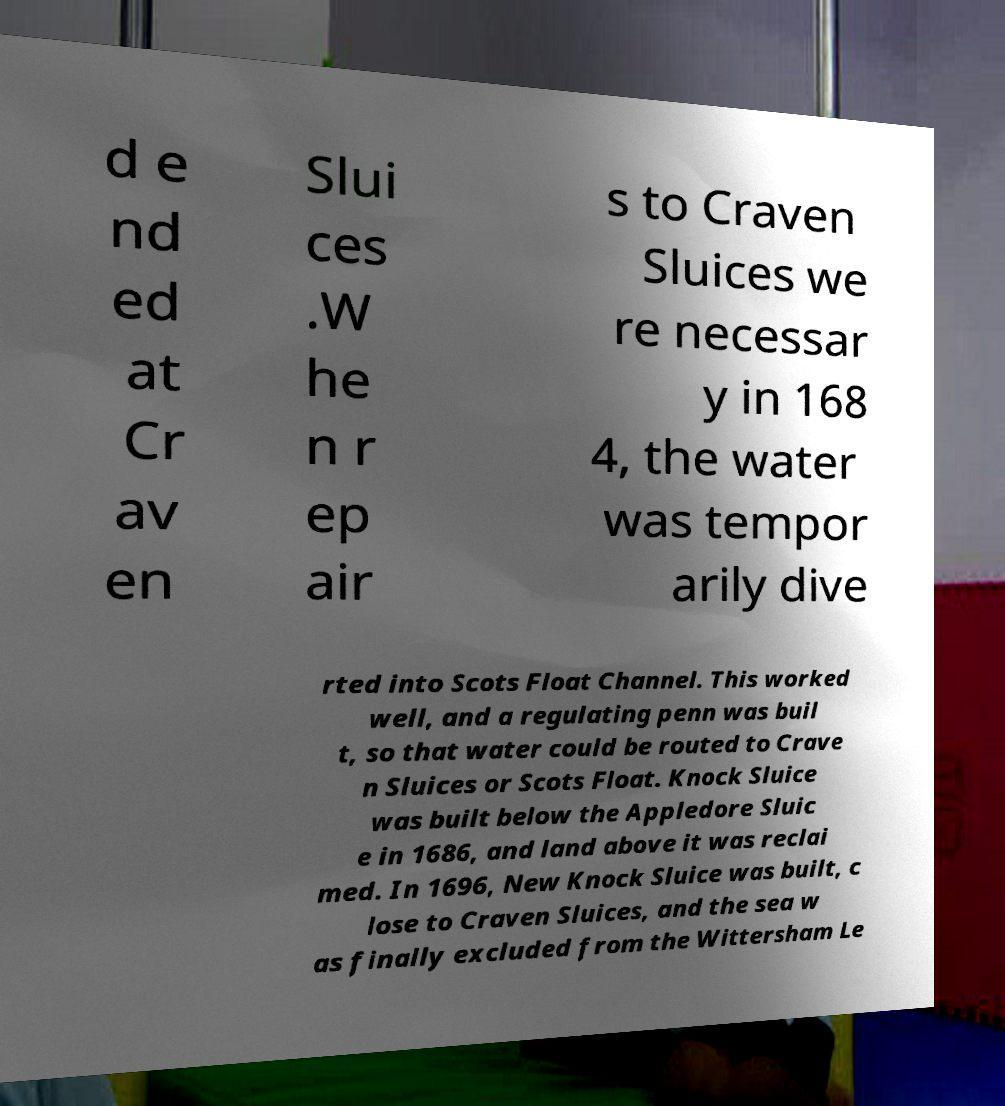Can you accurately transcribe the text from the provided image for me? d e nd ed at Cr av en Slui ces .W he n r ep air s to Craven Sluices we re necessar y in 168 4, the water was tempor arily dive rted into Scots Float Channel. This worked well, and a regulating penn was buil t, so that water could be routed to Crave n Sluices or Scots Float. Knock Sluice was built below the Appledore Sluic e in 1686, and land above it was reclai med. In 1696, New Knock Sluice was built, c lose to Craven Sluices, and the sea w as finally excluded from the Wittersham Le 